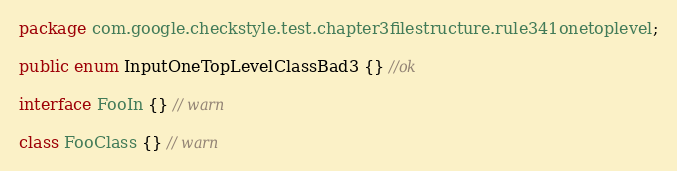<code> <loc_0><loc_0><loc_500><loc_500><_Java_>package com.google.checkstyle.test.chapter3filestructure.rule341onetoplevel;

public enum InputOneTopLevelClassBad3 {} //ok

interface FooIn {} // warn

class FooClass {} // warn


</code> 